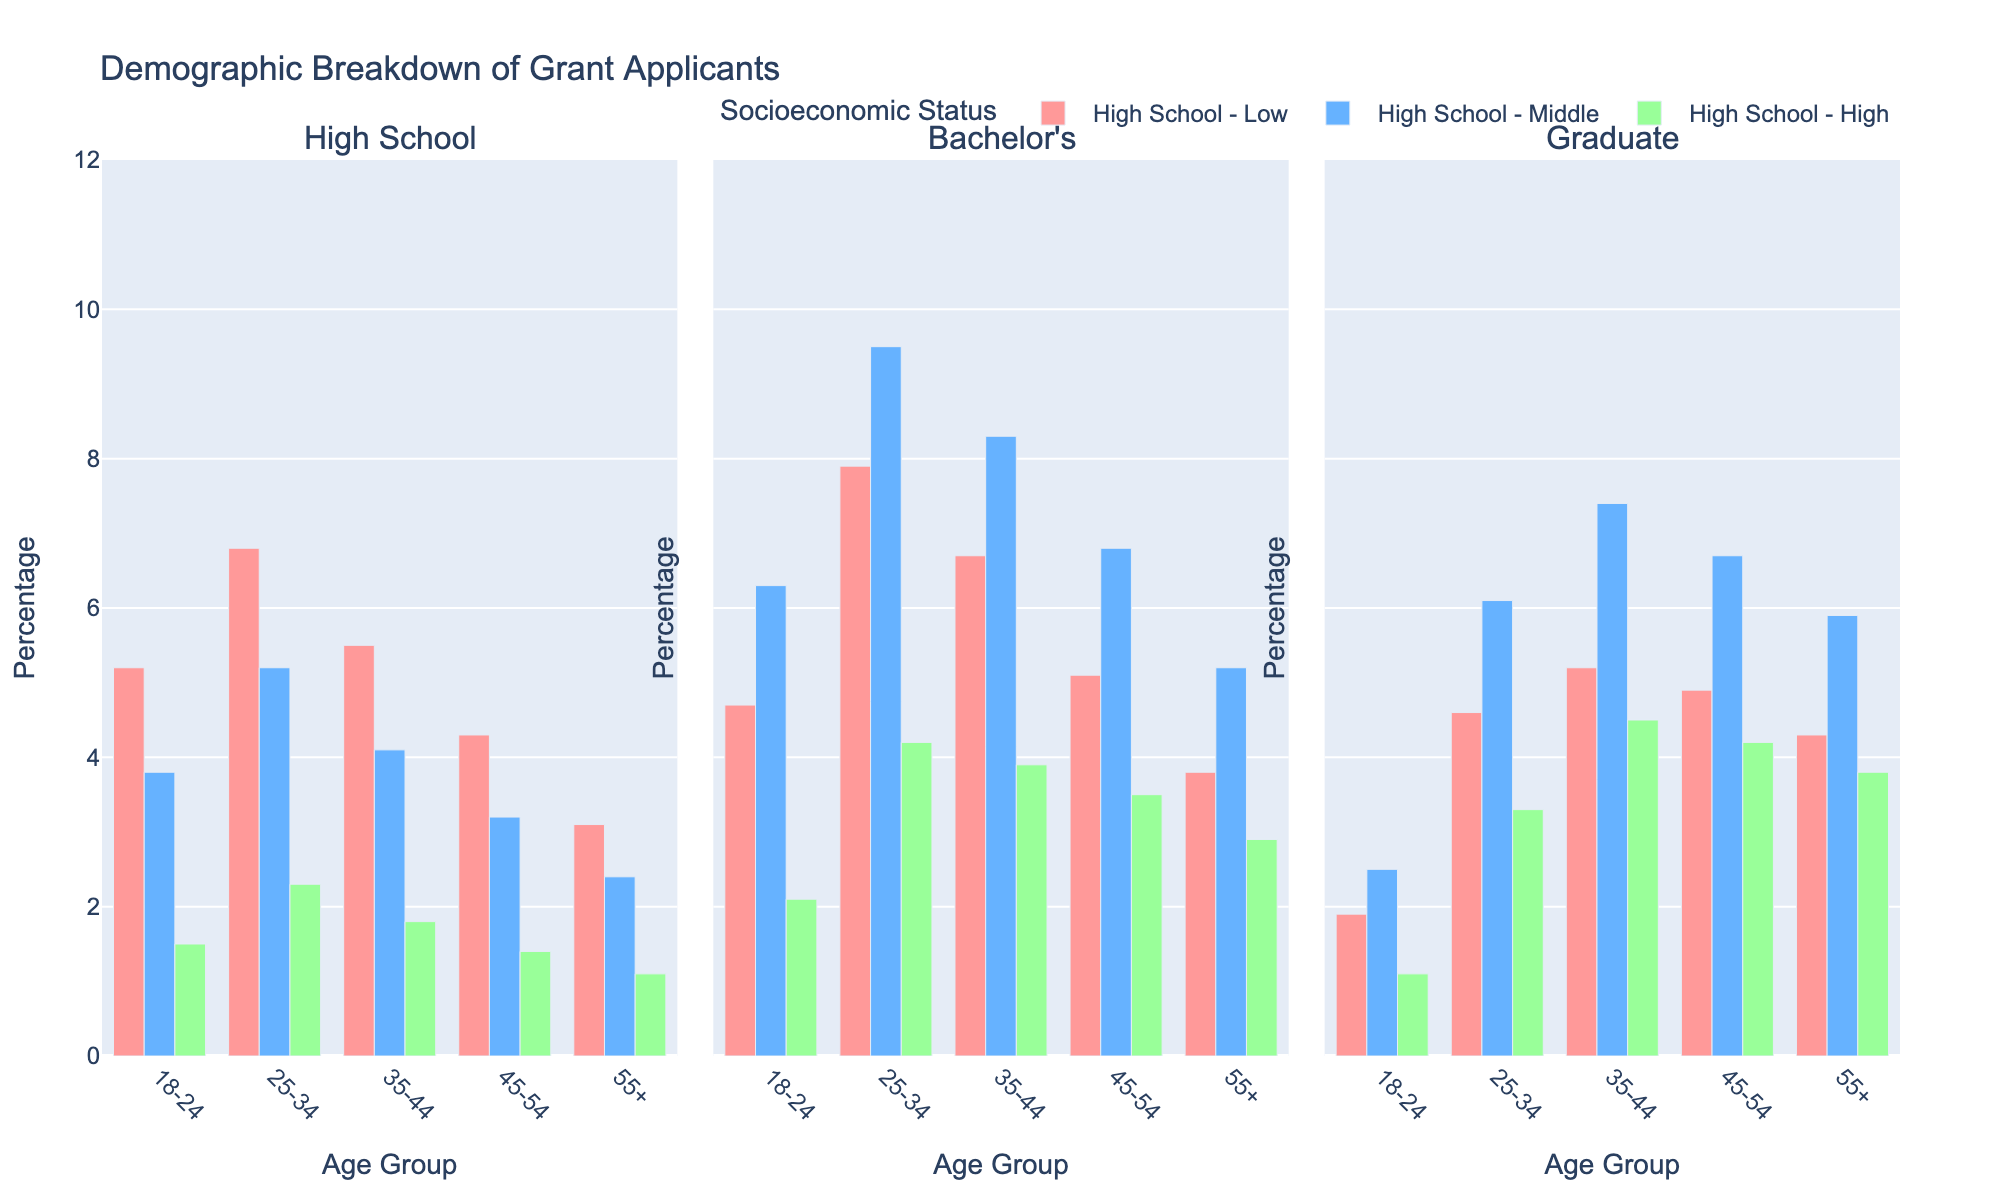Which age group has the highest percentage of graduate applicants with high socioeconomic status? Refer to the subplot for graduate education and look for the tallest bar in the high socioeconomic status group. The tallest bar for high SES graduates is found in the 35-44 age group.
Answer: 35-44 What is the average percentage of bachelor's degree applicants across all age groups with low socioeconomic status? Calculate the average percentage by summing the values for bachelor's degree applicants with low SES across all age groups and dividing by the number of age groups. The percentages are: 18-24 (4.7), 25-34 (7.9), 35-44 (6.7), 45-54 (5.1), and 55+ (3.8). The sum is 28.2, and the average is 28.2 / 5.
Answer: 5.64 In which socioeconomic status group do high school applicants aged 25-34 have a higher percentage compared to high school applicants aged 18-24? Compare the percentages within each socioeconomic status category for high school applicants aged 25-34 and 18-24. For low SES: 25-34 (6.8) vs. 18-24 (5.2), middle SES: 25-34 (5.2) vs. 18-24 (3.8), high SES: 25-34 (2.3) vs. 18-24 (1.5).
Answer: Low SES, Middle SES, and High SES Which age group has the smallest percentage difference between middle and high socioeconomic status for graduate applicants? Calculate the percentage difference for middle and high SES graduate applicants within each age group and find the smallest: 18-24 (2.5 - 1.1 = 1.4), 25-34 (6.1 - 3.3 = 2.8), 35-44 (7.4 - 4.5 = 2.9), 45-54 (6.7 - 4.2 = 2.5), 55+ (5.9 - 3.8 = 2.1).
Answer: 18-24 For bachelor's degree applicants, which socioeconomic status has the consistently highest percentage across all age groups? Compare the heights of the bars within the bachelor's degree subplots over all age groups. Check which SES consistently has the highest percentages. Middle SES has the highest bars in most age groups.
Answer: Middle SES What is the total percentage of applicants aged 35-44 with a graduate degree across all socioeconomic statuses? Sum the percentages for graduate degree applicants aged 35-44 across all SES categories: low (5.2), middle (7.4), high (4.5). The total is 5.2 + 7.4 + 4.5.
Answer: 17.1 Which socioeconomic status group shows the most variation in percentages across age groups for bachelor's degree applicants? Evaluate the range of percentages (highest - lowest) for each SES category in the bachelor's degree applicants subplot. Low SES (7.9 - 4.7 = 3.2), Middle SES (9.5 - 5.2 = 4.3), High SES (4.2 - 1.1 = 3.1). The middle SES shows the most variation.
Answer: Middle SES 